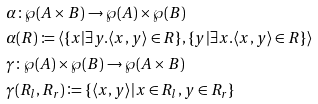<formula> <loc_0><loc_0><loc_500><loc_500>& \alpha \colon \wp ( A \times B ) \rightarrow \wp ( A ) \times \wp ( B ) \\ & \alpha ( R ) \coloneqq \langle \{ x | \exists y . \langle x , y \rangle \in R \} , \{ y | \exists x . \langle x , y \rangle \in R \} \rangle \\ & \gamma \colon \wp ( A ) \times \wp ( B ) \rightarrow \wp ( A \times B ) \\ & \gamma ( R _ { l } , R _ { r } ) \coloneqq \{ \langle x , y \rangle | x \in R _ { l } , y \in R _ { r } \}</formula> 